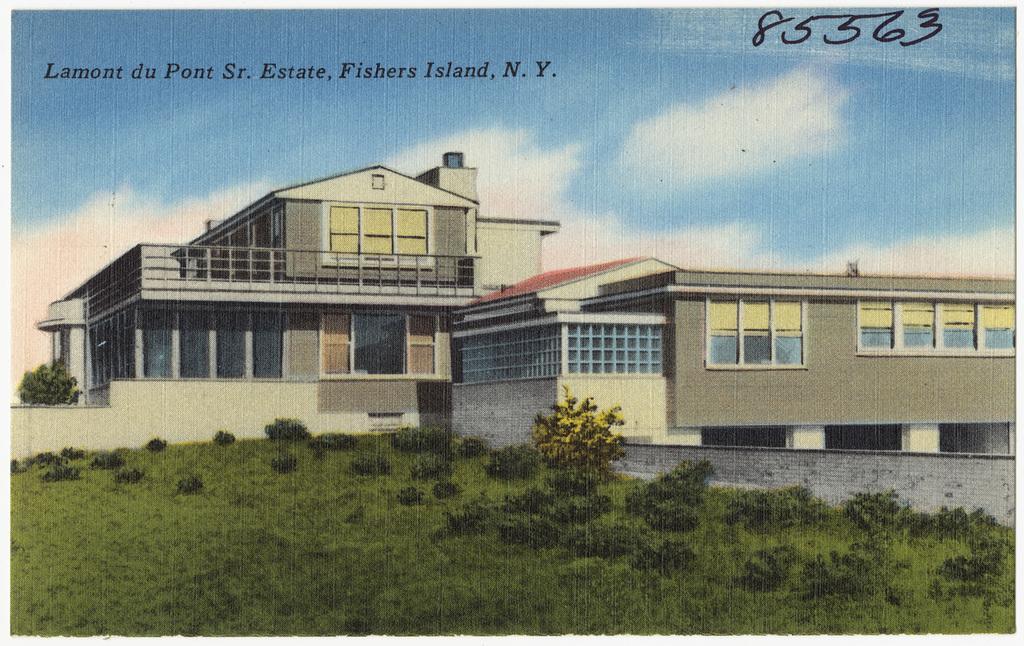Can you describe this image briefly? In this image I can see a picture in which I can see some grass on the ground, few plants, the wall and few buildings. In the background I can see the sky. 